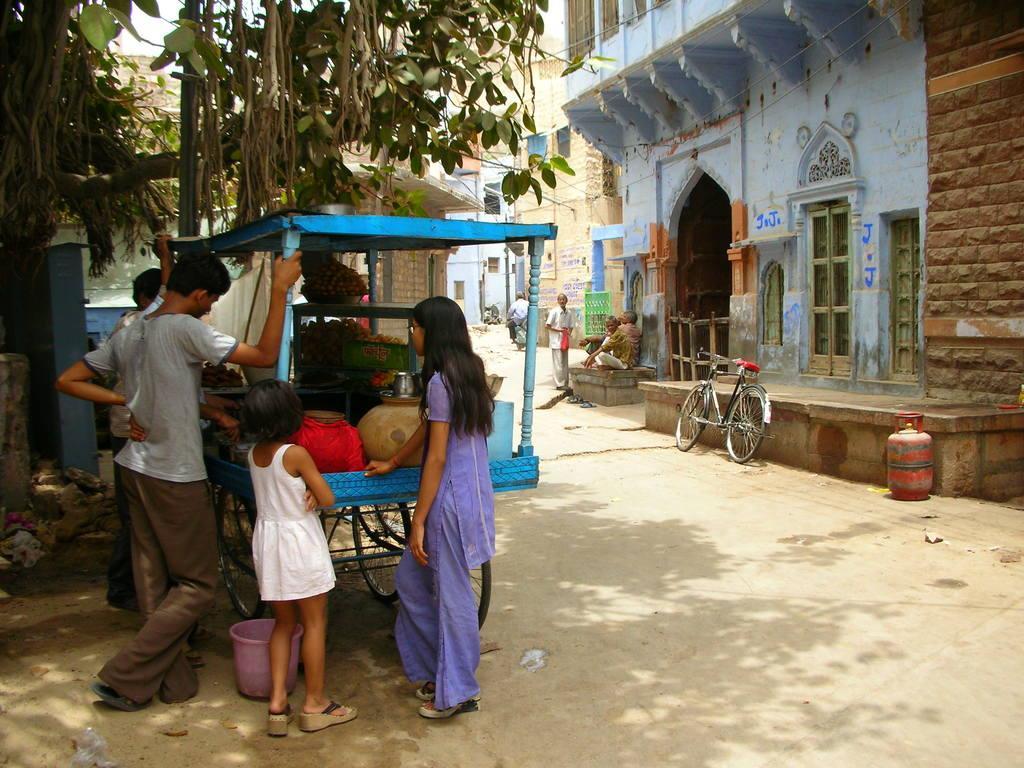How would you summarize this image in a sentence or two? In the image we can see there are people standing and some of them are sitting, they are wearing clothes. This is a bucket, gas cylinder, bicycle, footpath, building, window of the building, tree, pot, glass, stones and a white sky. 